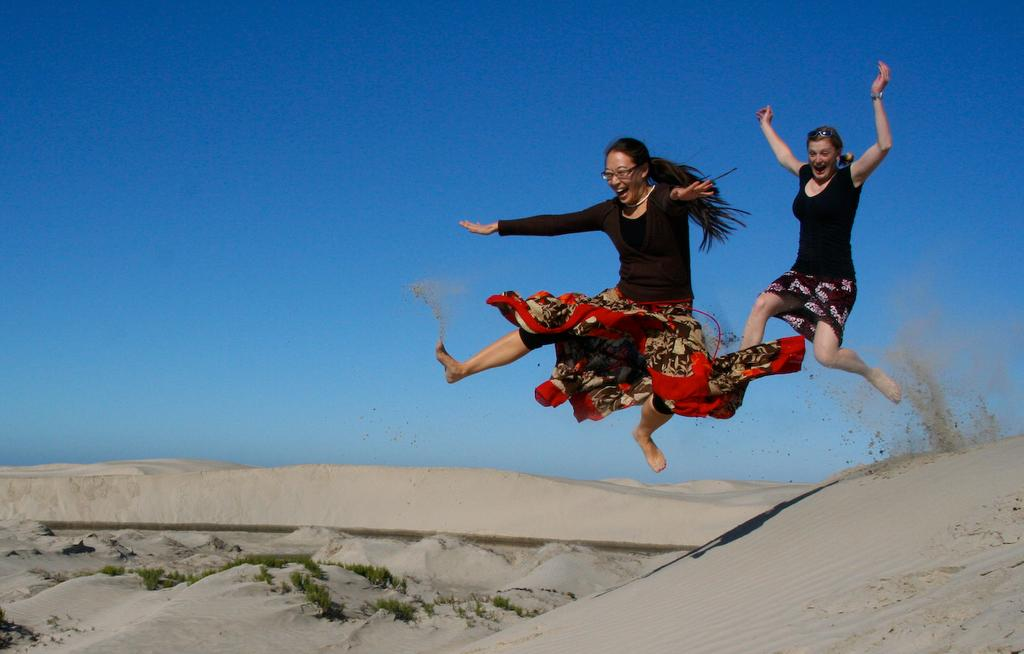How many people are in the image? There are two women in the image. What are the women doing in the image? The women are jumping. What type of surface is at the bottom of the image? There is sand at the bottom of the image. What can be seen in the middle of the image? There are plants in the middle of the image. What is visible at the top of the image? The sky is visible at the top of the image. How many rabbits can be seen hopping in the image? There are no rabbits present in the image. What type of basin is visible in the image? There is no basin present in the image. 